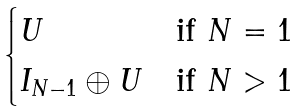<formula> <loc_0><loc_0><loc_500><loc_500>\begin{cases} U & \text {if } N = 1 \\ I _ { N - 1 } \oplus U & \text {if } N > 1 \end{cases}</formula> 